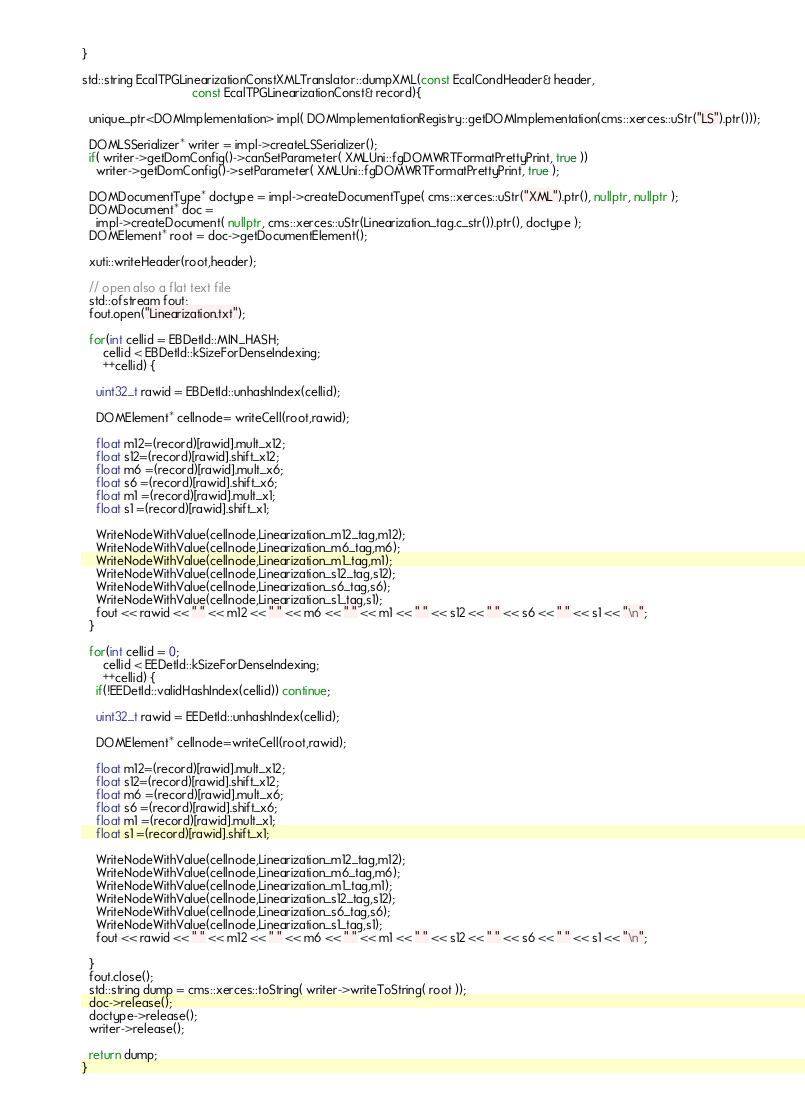<code> <loc_0><loc_0><loc_500><loc_500><_C++_>}

std::string EcalTPGLinearizationConstXMLTranslator::dumpXML(const EcalCondHeader& header,
							    const EcalTPGLinearizationConst& record){

  unique_ptr<DOMImplementation> impl( DOMImplementationRegistry::getDOMImplementation(cms::xerces::uStr("LS").ptr()));
  
  DOMLSSerializer* writer = impl->createLSSerializer();
  if( writer->getDomConfig()->canSetParameter( XMLUni::fgDOMWRTFormatPrettyPrint, true ))
    writer->getDomConfig()->setParameter( XMLUni::fgDOMWRTFormatPrettyPrint, true );
  
  DOMDocumentType* doctype = impl->createDocumentType( cms::xerces::uStr("XML").ptr(), nullptr, nullptr );
  DOMDocument* doc =
    impl->createDocument( nullptr, cms::xerces::uStr(Linearization_tag.c_str()).ptr(), doctype );
  DOMElement* root = doc->getDocumentElement();

  xuti::writeHeader(root,header);

  // open also a flat text file
  std::ofstream fout;
  fout.open("Linearization.txt");

  for(int cellid = EBDetId::MIN_HASH;
      cellid < EBDetId::kSizeForDenseIndexing;
      ++cellid) {

    uint32_t rawid = EBDetId::unhashIndex(cellid);

    DOMElement* cellnode= writeCell(root,rawid);	  

    float m12=(record)[rawid].mult_x12;
    float s12=(record)[rawid].shift_x12;
    float m6 =(record)[rawid].mult_x6;
    float s6 =(record)[rawid].shift_x6;
    float m1 =(record)[rawid].mult_x1;
    float s1 =(record)[rawid].shift_x1;

    WriteNodeWithValue(cellnode,Linearization_m12_tag,m12);
    WriteNodeWithValue(cellnode,Linearization_m6_tag,m6);
    WriteNodeWithValue(cellnode,Linearization_m1_tag,m1);	  	  	  
    WriteNodeWithValue(cellnode,Linearization_s12_tag,s12);
    WriteNodeWithValue(cellnode,Linearization_s6_tag,s6);
    WriteNodeWithValue(cellnode,Linearization_s1_tag,s1);
    fout << rawid << " " << m12 << " " << m6 << " " << m1 << " " << s12 << " " << s6 << " " << s1 << "\n";	  	  	  
  }

  for(int cellid = 0;
      cellid < EEDetId::kSizeForDenseIndexing;
      ++cellid) {
    if(!EEDetId::validHashIndex(cellid)) continue;
 
    uint32_t rawid = EEDetId::unhashIndex(cellid); 

    DOMElement* cellnode=writeCell(root,rawid);
  
    float m12=(record)[rawid].mult_x12;
    float s12=(record)[rawid].shift_x12;
    float m6 =(record)[rawid].mult_x6;
    float s6 =(record)[rawid].shift_x6;
    float m1 =(record)[rawid].mult_x1;
    float s1 =(record)[rawid].shift_x1;
     
    WriteNodeWithValue(cellnode,Linearization_m12_tag,m12);
    WriteNodeWithValue(cellnode,Linearization_m6_tag,m6);
    WriteNodeWithValue(cellnode,Linearization_m1_tag,m1);	  	  	  
    WriteNodeWithValue(cellnode,Linearization_s12_tag,s12);
    WriteNodeWithValue(cellnode,Linearization_s6_tag,s6);
    WriteNodeWithValue(cellnode,Linearization_s1_tag,s1);	  	  	  
    fout << rawid << " " << m12 << " " << m6 << " " << m1 << " " << s12 << " " << s6 << " " << s1 << "\n";	  	  	  
  
  }  
  fout.close();
  std::string dump = cms::xerces::toString( writer->writeToString( root ));
  doc->release();
  doctype->release();
  writer->release();

  return dump;
}
</code> 